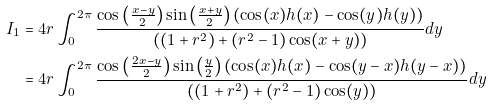Convert formula to latex. <formula><loc_0><loc_0><loc_500><loc_500>I _ { 1 } & = 4 r \int _ { 0 } ^ { 2 \pi } \frac { \cos \left ( \frac { x - y } { 2 } \right ) \sin \left ( \frac { x + y } { 2 } \right ) ( \cos ( x ) h ( x ) - \cos ( y ) h ( y ) ) } { ( ( 1 + r ^ { 2 } ) + ( r ^ { 2 } - 1 ) \cos ( x + y ) ) } d y \\ & = 4 r \int _ { 0 } ^ { 2 \pi } \frac { \cos \left ( \frac { 2 x - y } { 2 } \right ) \sin \left ( \frac { y } { 2 } \right ) ( \cos ( x ) h ( x ) - \cos ( y - x ) h ( y - x ) ) } { ( ( 1 + r ^ { 2 } ) + ( r ^ { 2 } - 1 ) \cos ( y ) ) } d y \\</formula> 